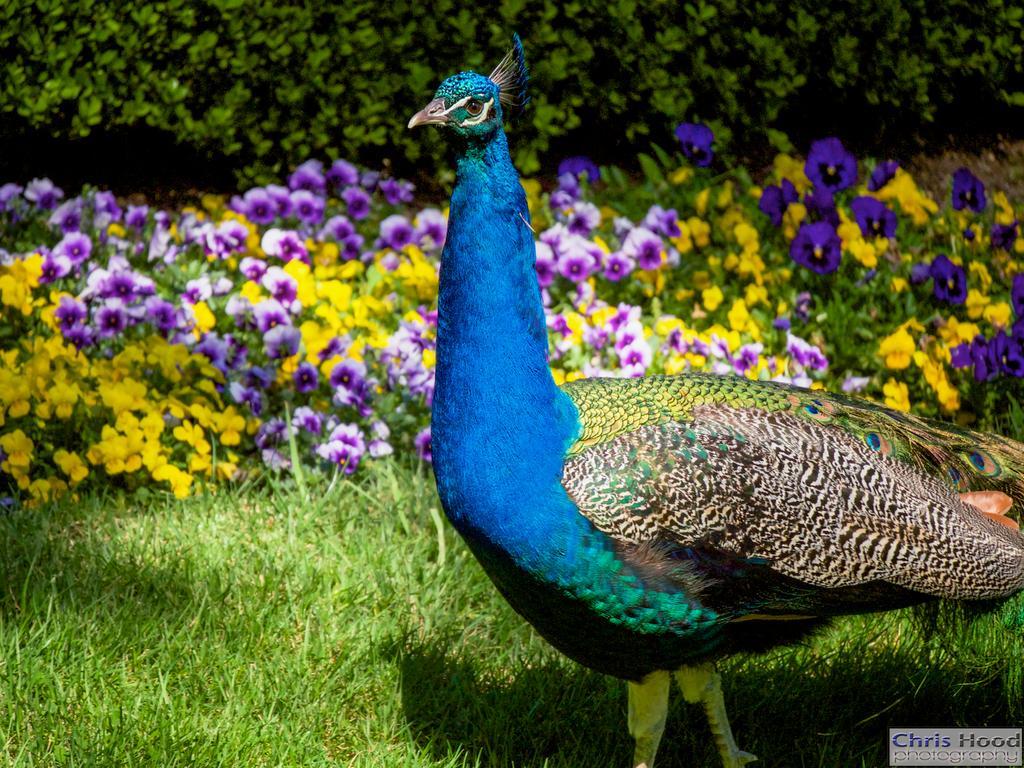Could you give a brief overview of what you see in this image? In this picture in the middle, we can see a peacock. In the background, we can see some plants with flowers and the flowers are in blue and yellow color, we can also see some trees, at the bottom there is a grass which is in green color. 